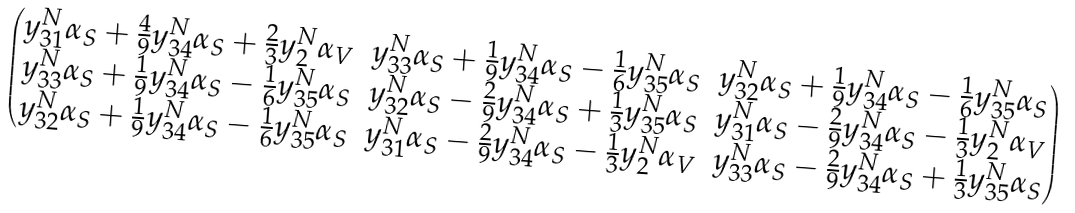Convert formula to latex. <formula><loc_0><loc_0><loc_500><loc_500>\begin{pmatrix} y _ { 3 1 } ^ { N } \alpha _ { S } + \frac { 4 } { 9 } y _ { 3 4 } ^ { N } \alpha _ { S } + \frac { 2 } { 3 } y _ { 2 } ^ { N } \alpha _ { V } & y _ { 3 3 } ^ { N } \alpha _ { S } + \frac { 1 } { 9 } y _ { 3 4 } ^ { N } \alpha _ { S } - \frac { 1 } { 6 } y _ { 3 5 } ^ { N } \alpha _ { S } & y _ { 3 2 } ^ { N } \alpha _ { S } + \frac { 1 } { 9 } y _ { 3 4 } ^ { N } \alpha _ { S } - \frac { 1 } { 6 } y _ { 3 5 } ^ { N } \alpha _ { S } \\ y _ { 3 3 } ^ { N } \alpha _ { S } + \frac { 1 } { 9 } y _ { 3 4 } ^ { N } \alpha _ { S } - \frac { 1 } { 6 } y _ { 3 5 } ^ { N } \alpha _ { S } & y _ { 3 2 } ^ { N } \alpha _ { S } - \frac { 2 } { 9 } y _ { 3 4 } ^ { N } \alpha _ { S } + \frac { 1 } { 3 } y _ { 3 5 } ^ { N } \alpha _ { S } & y _ { 3 1 } ^ { N } \alpha _ { S } - \frac { 2 } { 9 } y _ { 3 4 } ^ { N } \alpha _ { S } - \frac { 1 } { 3 } y _ { 2 } ^ { N } \alpha _ { V } \\ y _ { 3 2 } ^ { N } \alpha _ { S } + \frac { 1 } { 9 } y _ { 3 4 } ^ { N } \alpha _ { S } - \frac { 1 } { 6 } y _ { 3 5 } ^ { N } \alpha _ { S } & y _ { 3 1 } ^ { N } \alpha _ { S } - \frac { 2 } { 9 } y _ { 3 4 } ^ { N } \alpha _ { S } - \frac { 1 } { 3 } y _ { 2 } ^ { N } \alpha _ { V } & y _ { 3 3 } ^ { N } \alpha _ { S } - \frac { 2 } { 9 } y _ { 3 4 } ^ { N } \alpha _ { S } + \frac { 1 } { 3 } y _ { 3 5 } ^ { N } \alpha _ { S } \end{pmatrix}</formula> 